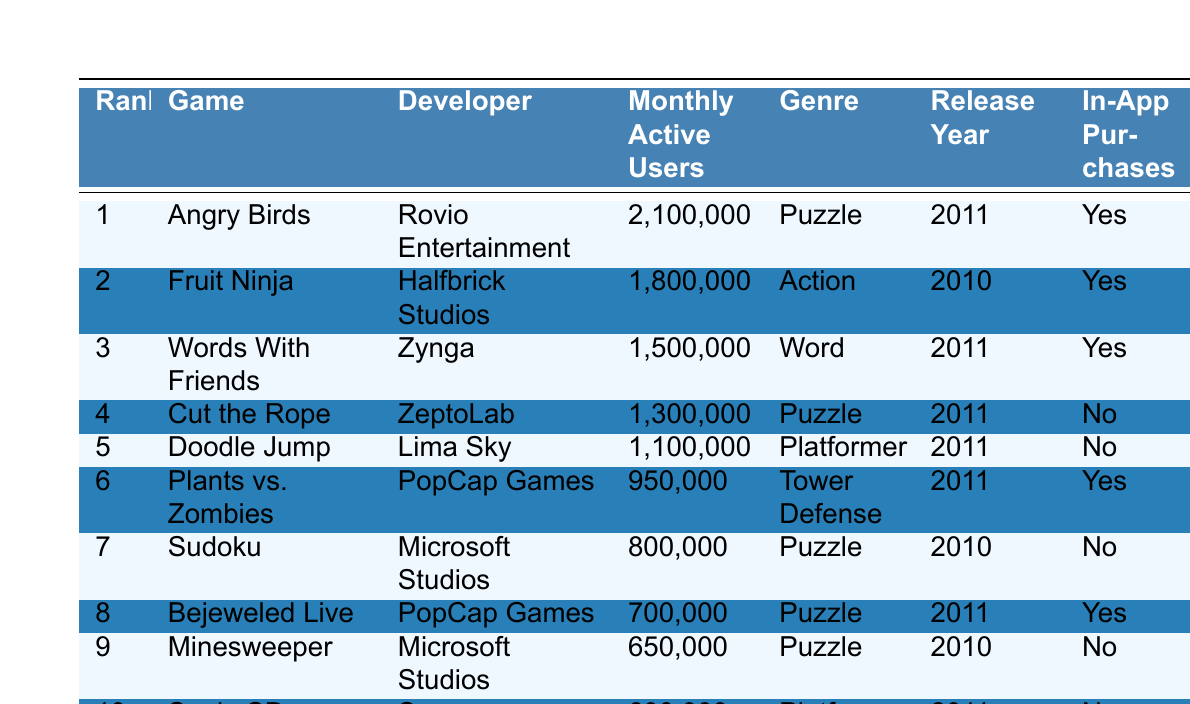What is the game with the highest monthly active users? The table shows that "Angry Birds" has 2,100,000 monthly active users, which is the highest among all the listed games.
Answer: Angry Birds Which game was released in 2010 and has the most active users? The only games released in 2010 are "Fruit Ninja" with 1,800,000 users and "Sudoku" with 800,000 users. "Fruit Ninja" has the highest active users among the two.
Answer: Fruit Ninja How many games have in-app purchases? Counting the "In-App Purchases" column, the games that have them are "Angry Birds," "Fruit Ninja," "Words With Friends," "Plants vs. Zombies," and "Bejeweled Live," adding up to 5 games.
Answer: 5 What is the average number of monthly active users across the top 10 games? Summing all monthly active users gives 2,100,000 + 1,800,000 + 1,500,000 + 1,300,000 + 1,100,000 + 950,000 + 800,000 + 700,000 + 650,000 + 600,000 = 12,650,000. Dividing by 10 yields an average of 1,265,000 users.
Answer: 1,265,000 Which genre has the most games listed in the top 10? The "Puzzle" genre appears 5 times (Angry Birds, Cut the Rope, Sudoku, Bejeweled Live, Minesweeper) compared to other genres, so it has the most occurrences.
Answer: Puzzle Is "Sonic CD" a puzzle game? "Sonic CD" is classified as a "Platformer" in the table, which is not the same as a puzzle game.
Answer: No Which developer has the most games in the top 10? "PopCap Games" has 2 games ("Plants vs. Zombies" and "Bejeweled Live") listed in the top 10, which is more than any other developer.
Answer: PopCap Games What is the difference in monthly active users between the first and last game? The difference is 2,100,000 (Angry Birds) - 600,000 (Sonic CD) = 1,500,000 monthly active users.
Answer: 1,500,000 How many games are categorized as Platformer? "Doodle Jump" and "Sonic CD" are listed as Platformer, so there are 2 games in that genre.
Answer: 2 Which game is developed by Microsoft Studios and how many monthly active users does it have? "Sudoku" and "Minesweeper" are developed by Microsoft Studios. "Sudoku" has 800,000 users and "Minesweeper" has 650,000 users.
Answer: Sudoku (800,000), Minesweeper (650,000) 